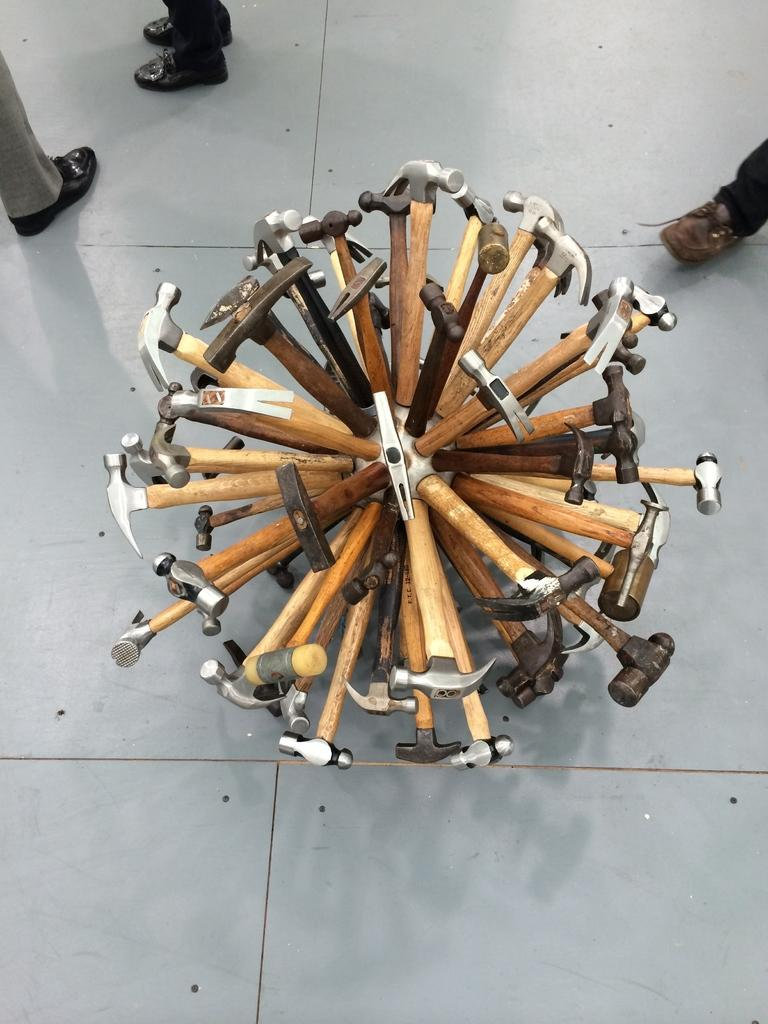What body parts of people can be seen in the image? There are people's legs with footwear visible in the image. What type of objects are present in the image? There are hammers and tools in the image. How many cats can be seen in the image? There are no cats present in the image. What type of beef is being prepared in the image? There is no beef present in the image. 